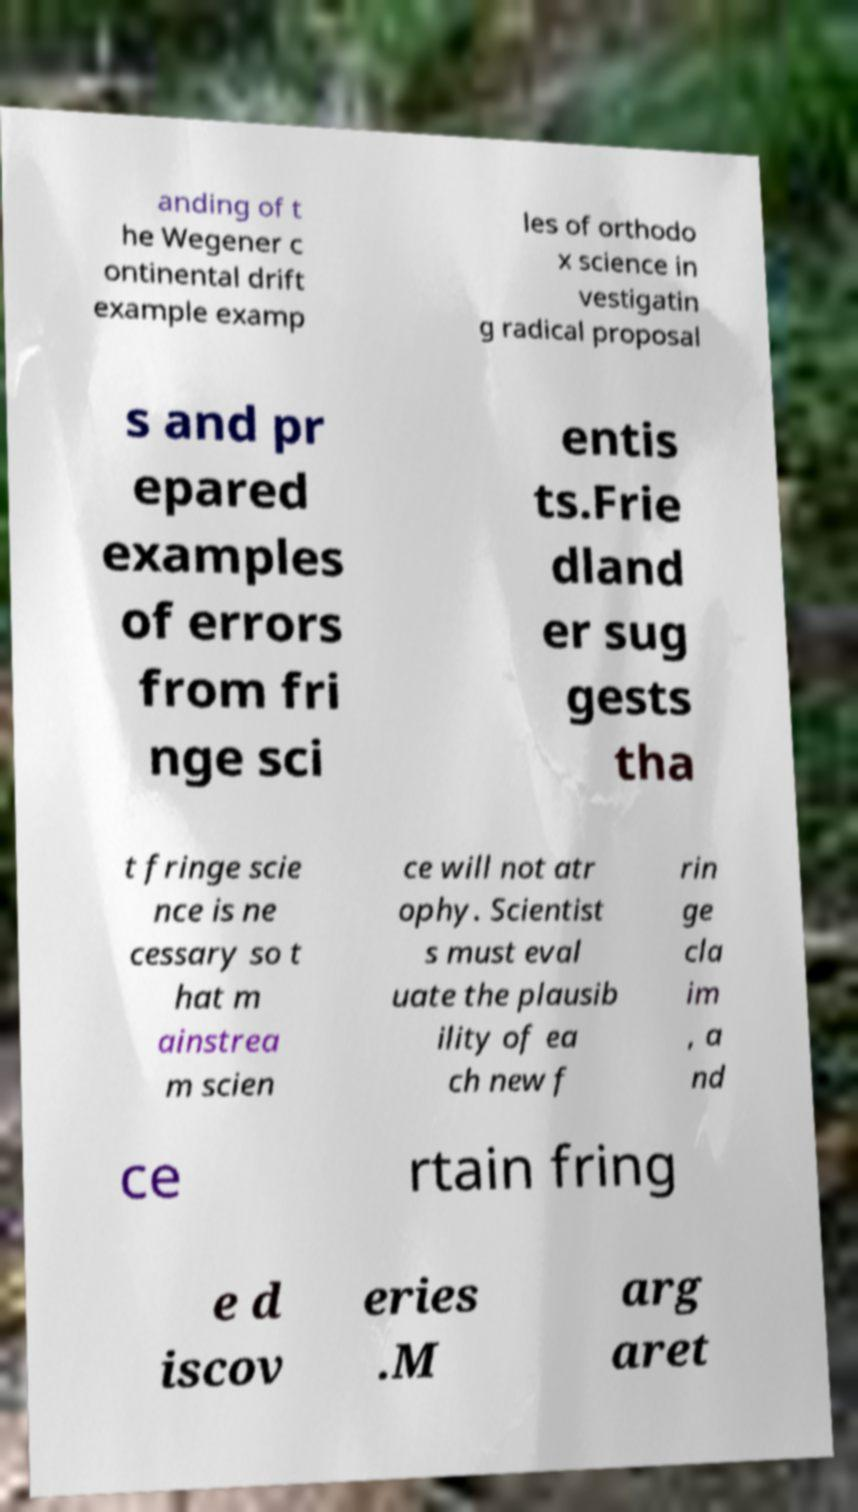Can you read and provide the text displayed in the image?This photo seems to have some interesting text. Can you extract and type it out for me? anding of t he Wegener c ontinental drift example examp les of orthodo x science in vestigatin g radical proposal s and pr epared examples of errors from fri nge sci entis ts.Frie dland er sug gests tha t fringe scie nce is ne cessary so t hat m ainstrea m scien ce will not atr ophy. Scientist s must eval uate the plausib ility of ea ch new f rin ge cla im , a nd ce rtain fring e d iscov eries .M arg aret 